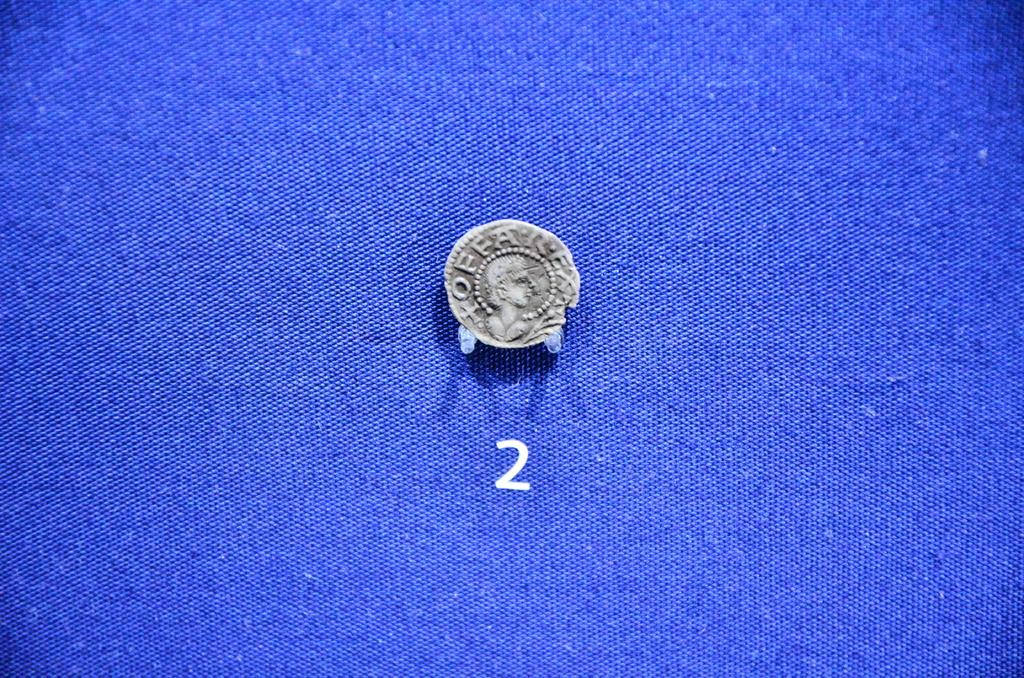<image>
Relay a brief, clear account of the picture shown. The very old coin shown has the letter OFFA written on it. 